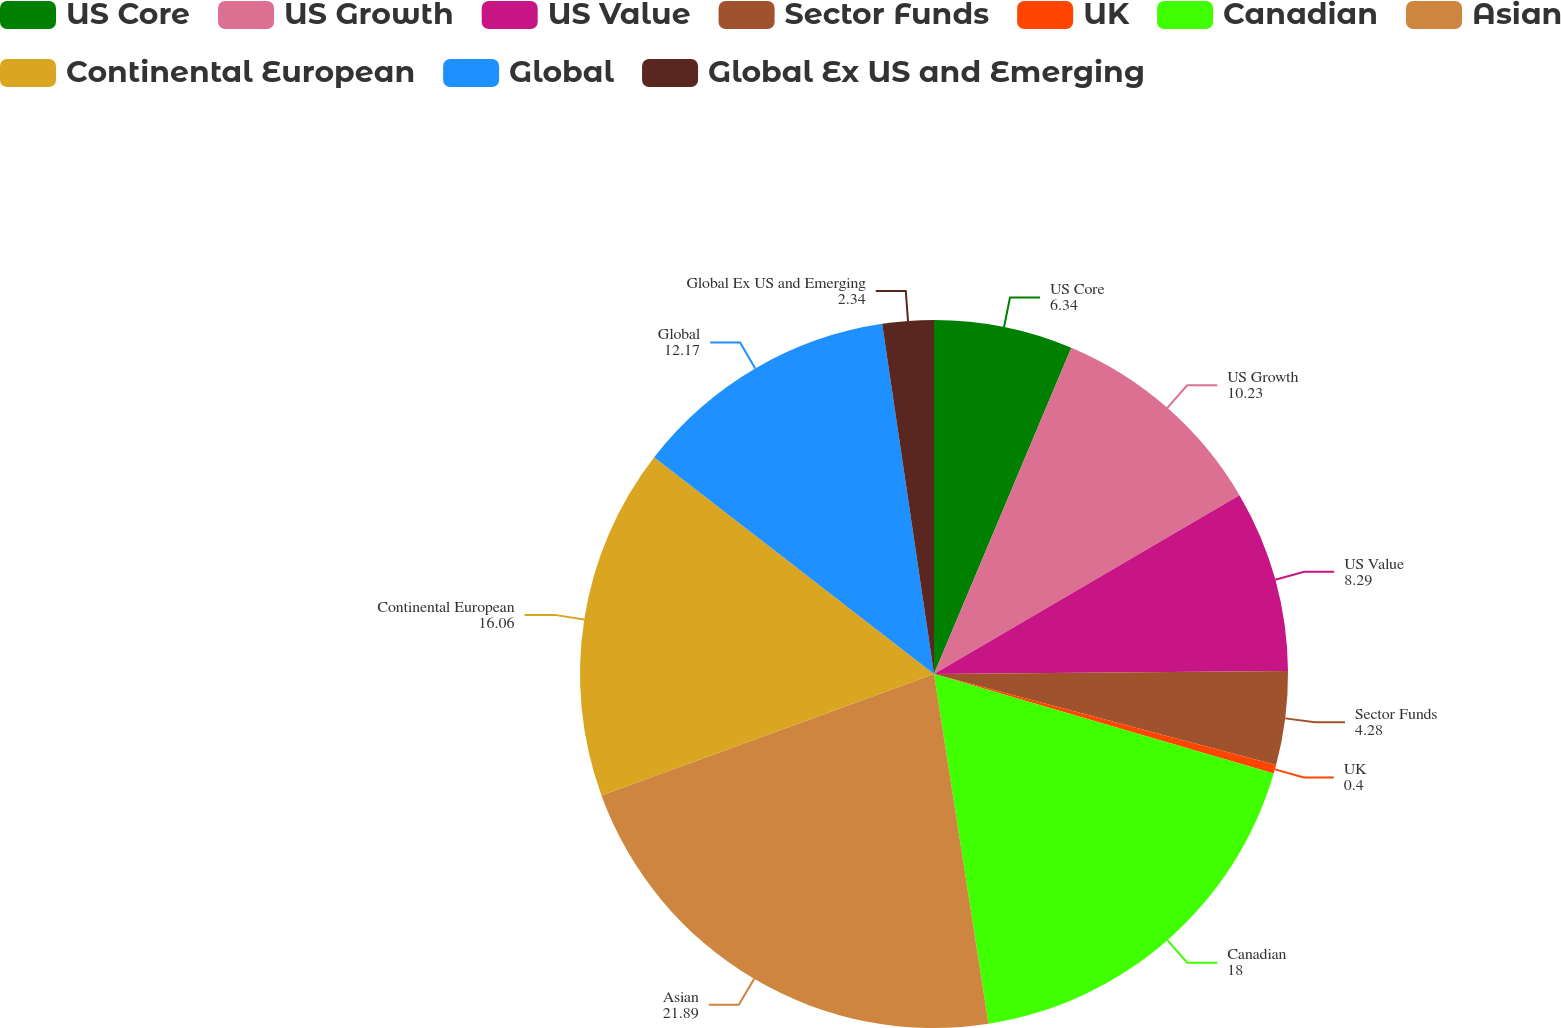Convert chart to OTSL. <chart><loc_0><loc_0><loc_500><loc_500><pie_chart><fcel>US Core<fcel>US Growth<fcel>US Value<fcel>Sector Funds<fcel>UK<fcel>Canadian<fcel>Asian<fcel>Continental European<fcel>Global<fcel>Global Ex US and Emerging<nl><fcel>6.34%<fcel>10.23%<fcel>8.29%<fcel>4.28%<fcel>0.4%<fcel>18.0%<fcel>21.89%<fcel>16.06%<fcel>12.17%<fcel>2.34%<nl></chart> 